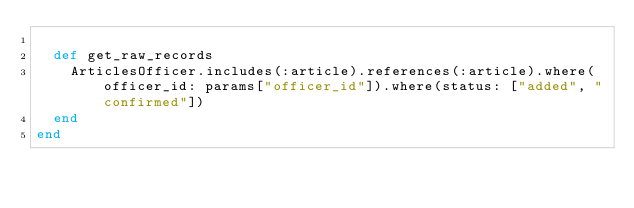Convert code to text. <code><loc_0><loc_0><loc_500><loc_500><_Ruby_>
  def get_raw_records
    ArticlesOfficer.includes(:article).references(:article).where(officer_id: params["officer_id"]).where(status: ["added", "confirmed"])
  end
end
</code> 